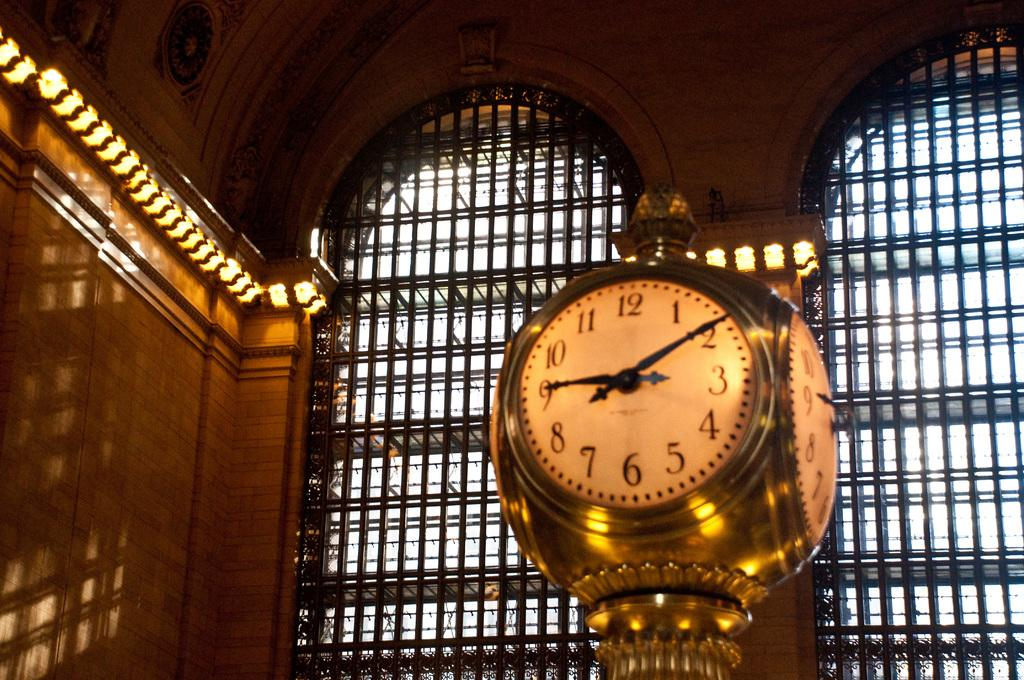<image>
Provide a brief description of the given image. A golden clock in a station shows that the time is now 9:09. 